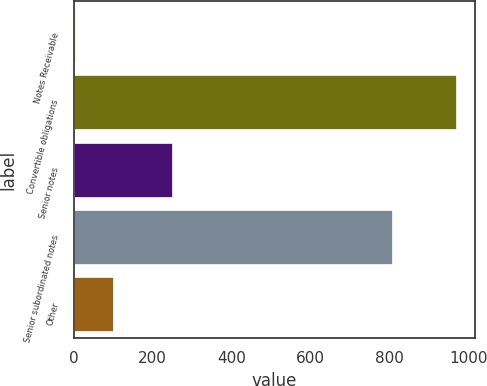Convert chart. <chart><loc_0><loc_0><loc_500><loc_500><bar_chart><fcel>Notes Receivable<fcel>Convertible obligations<fcel>Senior notes<fcel>Senior subordinated notes<fcel>Other<nl><fcel>2.7<fcel>969.1<fcel>250<fcel>806.3<fcel>99.34<nl></chart> 